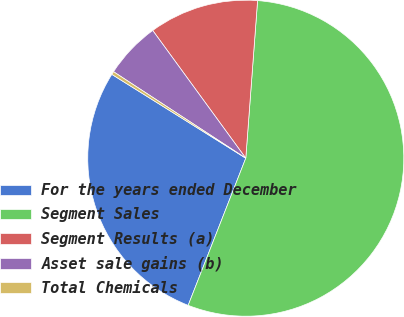<chart> <loc_0><loc_0><loc_500><loc_500><pie_chart><fcel>For the years ended December<fcel>Segment Sales<fcel>Segment Results (a)<fcel>Asset sale gains (b)<fcel>Total Chemicals<nl><fcel>27.96%<fcel>54.75%<fcel>11.21%<fcel>5.76%<fcel>0.32%<nl></chart> 